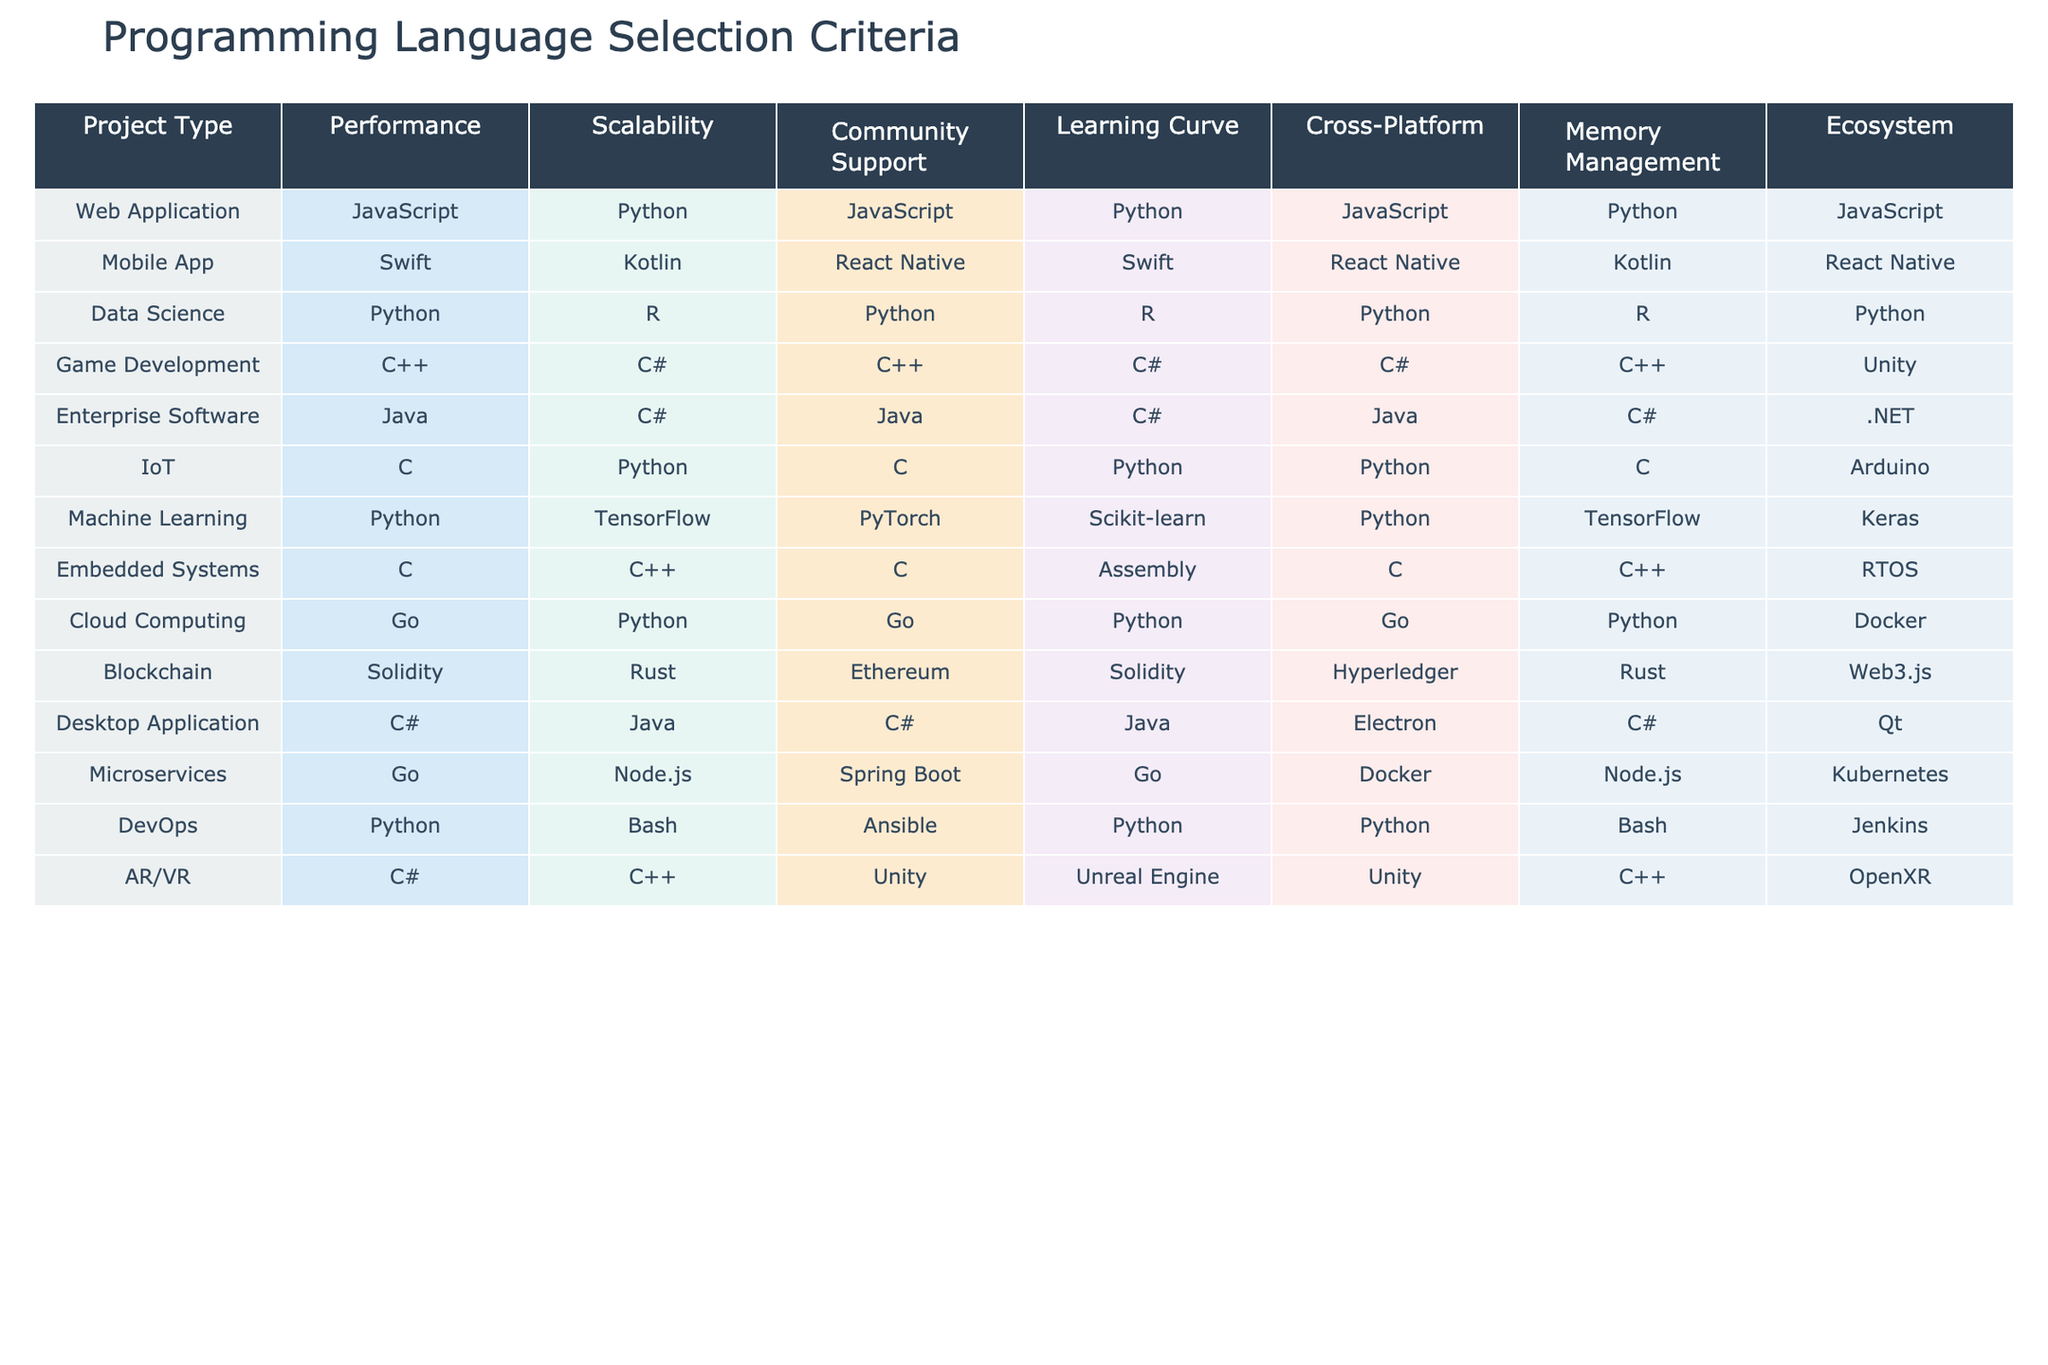What is the programming language recommended for Data Science projects? The table shows that Python is listed for both Performance and Ecosystem, and it is also the only language mentioned for this category.
Answer: Python Which project type has the widest range of programming languages suitable for its development? By examining the different project types and their corresponding programming languages in the table, Game Development has the highest diversity with four languages listed (C++, C#, Unity).
Answer: Game Development Is there a programming language that is suitable for both Web Application and Mobile App development? Comparing the relevant columns, JavaScript is indicated as the language for Web Application, while React Native is shown for Mobile App; they do not match, so the answer is no.
Answer: No What is the average number of programming languages listed for each project type? There are a total of 8 project types, with a sum of 27 programming languages listed across these categories (counting languages uniquely per project type). Therefore, the average is 27/8 = 3.375.
Answer: 3.375 How many programming languages use Python for Machine Learning in terms of Performance and Learning Curve? The table indicates Python for both Performance and Learning Curve in the Machine Learning category, making it the only language for these criteria.
Answer: 2 Which project type favors C++ in both Performance and Memory Management? The table indicates that for Game Development the programming language C++ is favored in both Performance and Memory Management columns.
Answer: Game Development Is Kotlin listed under Community Support for Mobile App projects? By checking the relevant section in the table for Mobile App development, Kotlin is not listed there; instead, React Native is mentioned.
Answer: No Which project type uses Go as the only language for Scalability? Looking at the entry for Cloud Computing, the table clearly states Go as the language for Scalability, making it the only one.
Answer: Cloud Computing 